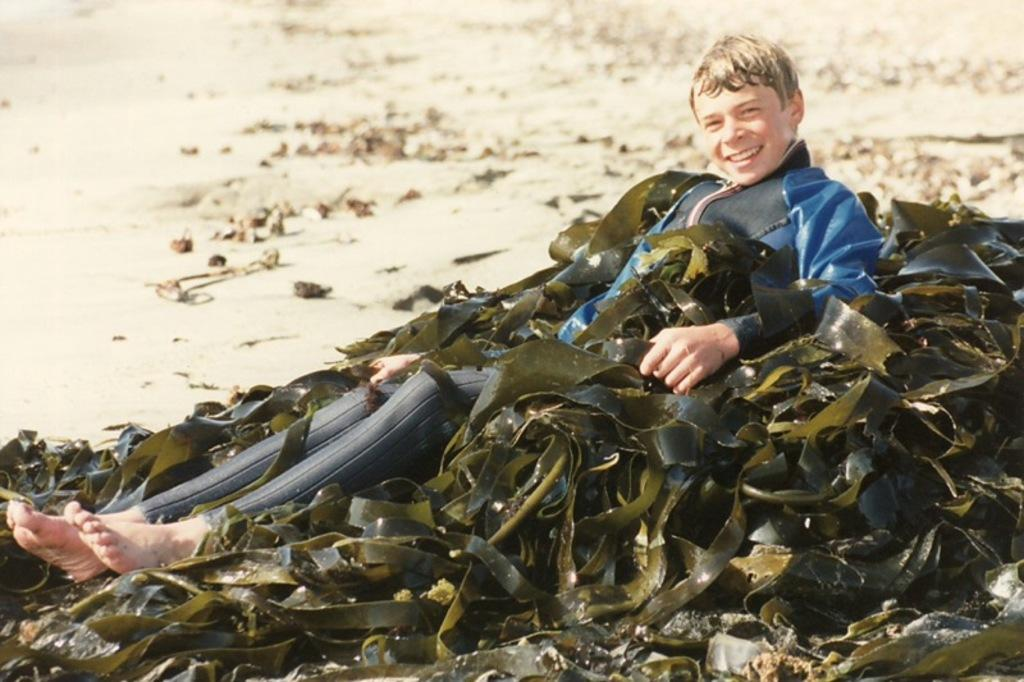Who is in the image? There is a person in the image. What is the person doing in the image? The person is smiling. What can be seen behind the person in the image? There is sand visible in the background of the image. What is the person's relationship to the green color belts in the image? The person is present between green color belts. What type of pail is being used to measure the person's heart rate in the image? There is no pail or heart rate measurement present in the image. What is the chance of the person winning a prize in the image? The image does not provide any information about the person winning a prize or any chance of winning. 